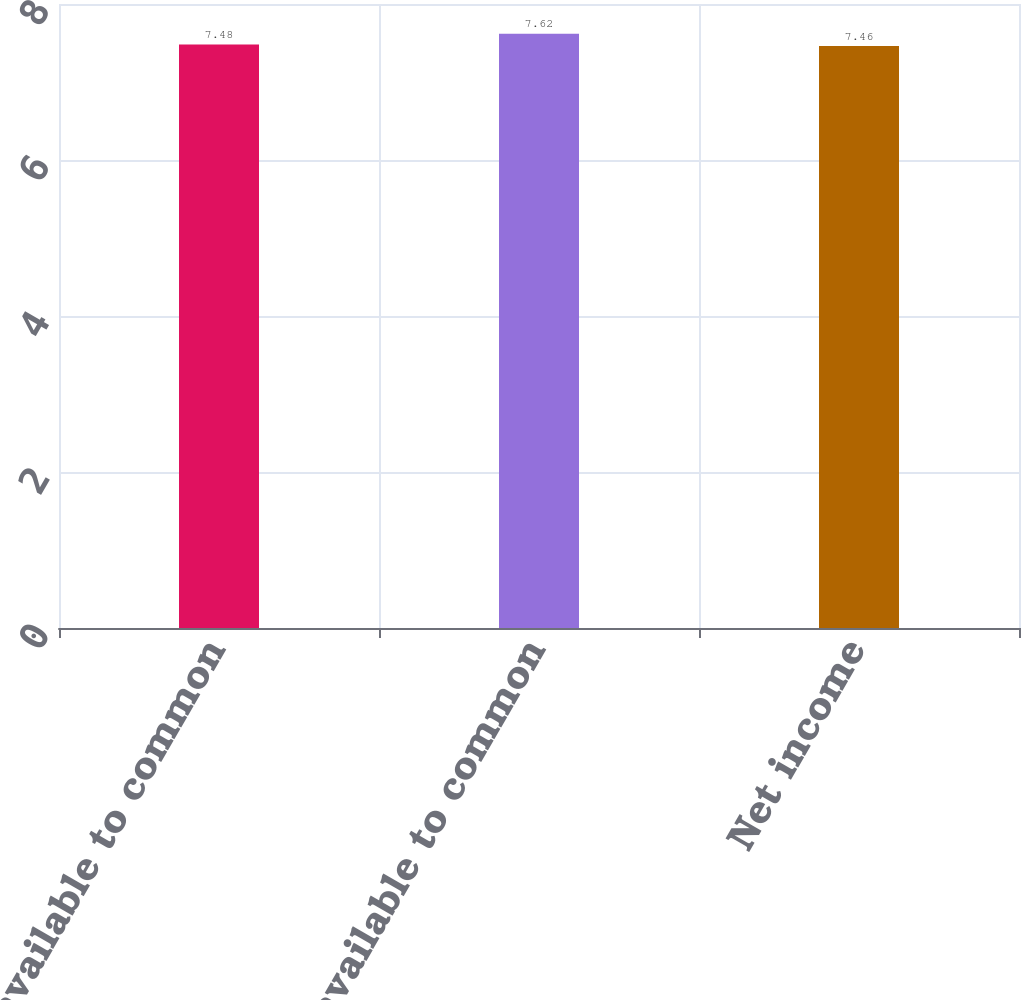Convert chart. <chart><loc_0><loc_0><loc_500><loc_500><bar_chart><fcel>Income available to common<fcel>Net income available to common<fcel>Net income<nl><fcel>7.48<fcel>7.62<fcel>7.46<nl></chart> 